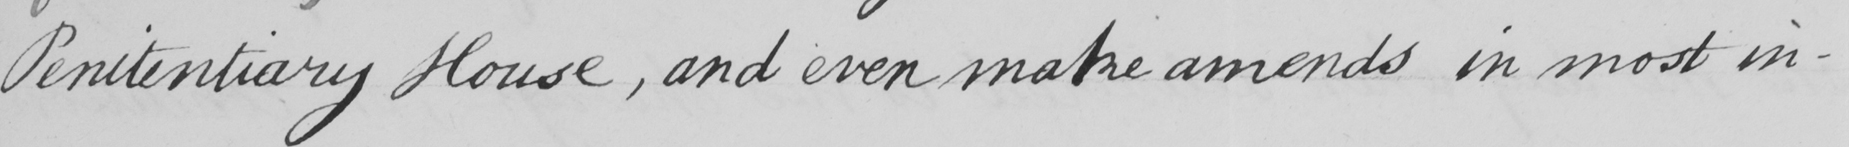What does this handwritten line say? Penitentiary House , and even make amends in most in- 